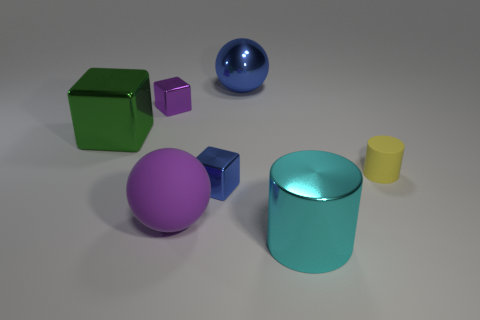Is there a red cube made of the same material as the big blue object? No, there is no red cube present. The objects visible include a green cube, a purple sphere, a small purple cube, a big blue sphere, a cyan cylinder, and a small yellow cylinder. The materials of these objects appear to be uniform in terms of their reflective characteristics, suggesting that they could be made of the same type of material with varying colors. 